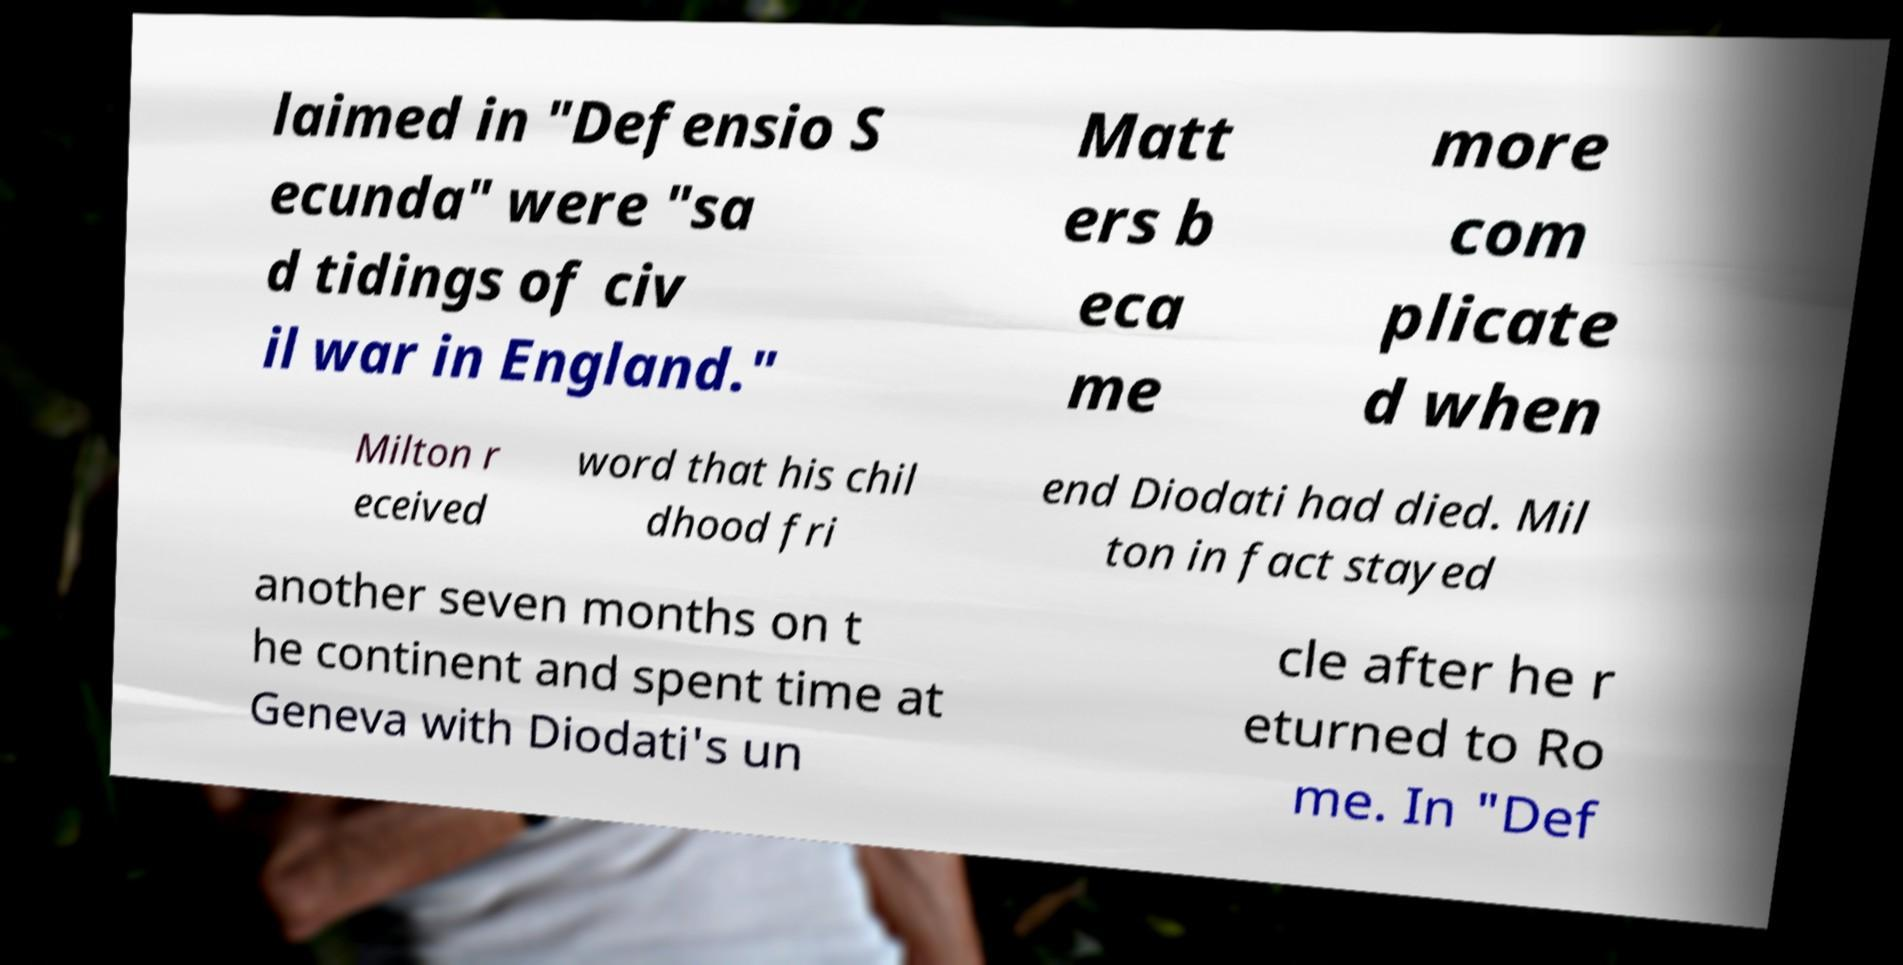Can you accurately transcribe the text from the provided image for me? laimed in "Defensio S ecunda" were "sa d tidings of civ il war in England." Matt ers b eca me more com plicate d when Milton r eceived word that his chil dhood fri end Diodati had died. Mil ton in fact stayed another seven months on t he continent and spent time at Geneva with Diodati's un cle after he r eturned to Ro me. In "Def 